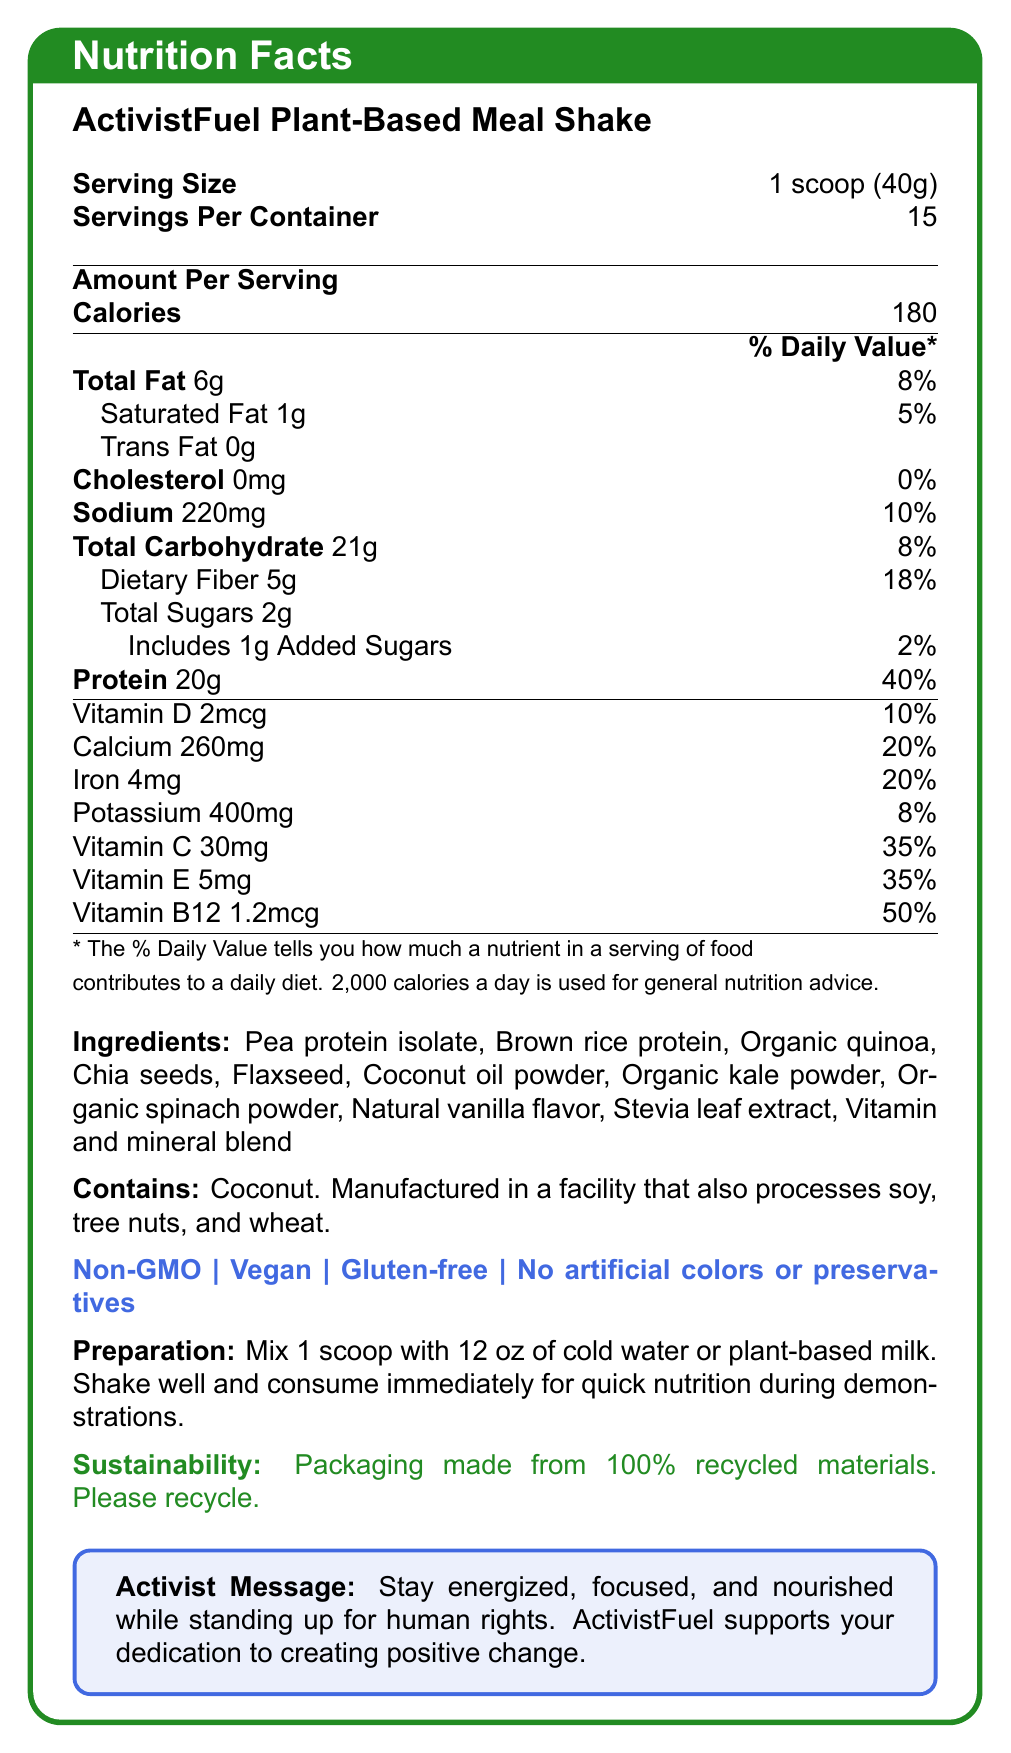What is the serving size for the ActivistFuel Plant-Based Meal Shake? The serving size is clearly stated as "1 scoop (40g)" in the document.
Answer: 1 scoop (40g) What is the total carbohydrate content per serving? The document lists "Total Carbohydrate" as "21g" per serving.
Answer: 21g Which of the following nutrients has the highest % Daily Value per serving? A. Vitamin D B. Calcium C. Protein D. Vitamin C The % Daily Value for Protein is 40%, which is higher than the listed percentages for other options.
Answer: C. Protein Is the ActivistFuel Plant-Based Meal Shake gluten-free? The document states that the product is "Gluten-free" under special features.
Answer: Yes How many servings are there in a container? The document lists "Servings Per Container" as 15.
Answer: 15 What ingredients are included in the meal shake? The document provides a list of ingredients: "Pea protein isolate, Brown rice protein, Organic quinoa, Chia seeds, Flaxseed, Coconut oil powder, Organic kale powder, Organic spinach powder, Natural vanilla flavor, Stevia leaf extract, Vitamin and mineral blend."
Answer: Pea protein isolate, Brown rice protein, Organic quinoa, Chia seeds, Flaxseed, Coconut oil powder, Organic kale powder, Organic spinach powder, Natural vanilla flavor, Stevia leaf extract, Vitamin and mineral blend Does the meal shake contain artificial colors or preservatives? It's explicitly stated that the product has "No artificial colors or preservatives" under special features.
Answer: No What is the % Daily Value of Vitamin C per serving? The document lists the % Daily Value for Vitamin C as 35%.
Answer: 35% Which nutrient has no content in the shake? A. Cholesterol B. Sodium C. Total Sugars The document states "Cholesterol 0mg," indicating there is no cholesterol content in the shake.
Answer: A. Cholesterol Is coconut an allergen in the ActivistFuel Plant-Based Meal Shake? The allergen information section states, "Contains coconut."
Answer: Yes Summarize the main idea of the document. The document contains detailed nutrition facts, ingredients, allergen information, and special features, highlighting the shake's suitability for activists due to its convenience, nutritional value, and ethical considerations.
Answer: The ActivistFuel Plant-Based Meal Shake provides a comprehensive nutritional profile with a focus on quick, portable nutrition for human rights activists. It is vegan, non-GMO, gluten-free, and includes high amounts of protein, vitamins, and minerals without artificial colors or preservatives. The product emphasizes sustainability and supports activists in their efforts. What is the ingredient responsible for the vanilla flavor in the shake? The document lists "Natural vanilla flavor" as one of the ingredients.
Answer: Natural vanilla flavor How many grams of dietary fiber does one serving of the meal shake contain? The document states, "Dietary Fiber 5g."
Answer: 5g Can the protein content be increased by consuming more than one serving at a time? Since each serving contains 20g of protein, consuming more servings would increase the total protein intake.
Answer: Yes What facilities may potentially process the meal shake? The allergen information section mentions that the shake is "Manufactured in a facility that also processes soy, tree nuts, and wheat."
Answer: Facilities that process soy, tree nuts, and wheat Does the ActivistFuel Plant-Based Meal Shake include added sugars? The document lists "Includes 1g Added Sugars."
Answer: Yes What are the instructions for preparing the shake? The preparation instructions section provides this detailed method for making the shake.
Answer: Mix 1 scoop with 12 oz of cold water or plant-based milk. Shake well and consume immediately for quick nutrition during demonstrations. How is the packaging of the ActivistFuel Plant-Based Meal Shake described? The sustainability note mentions that the packaging is made from 100% recycled materials and encourages recycling.
Answer: Packaging made from 100% recycled materials. Please recycle. Does the meal shake provide any Vitamin B12? The document lists Vitamin B12 as 1.2mcg, making up 50% of the daily value.
Answer: Yes What is the amount of saturated fat per serving? The document mentions that each serving contains "Saturated Fat 1g."
Answer: 1g How much calcium is in a serving of the shake? The amount of calcium per serving is listed as 260mg.
Answer: 260mg What benefit does the shake claim to provide to activists? The activist message emphasizes the shake's role in supporting activists' energy and focus during demonstrations.
Answer: Helps keep activists energized, focused, and nourished while standing up for human rights 